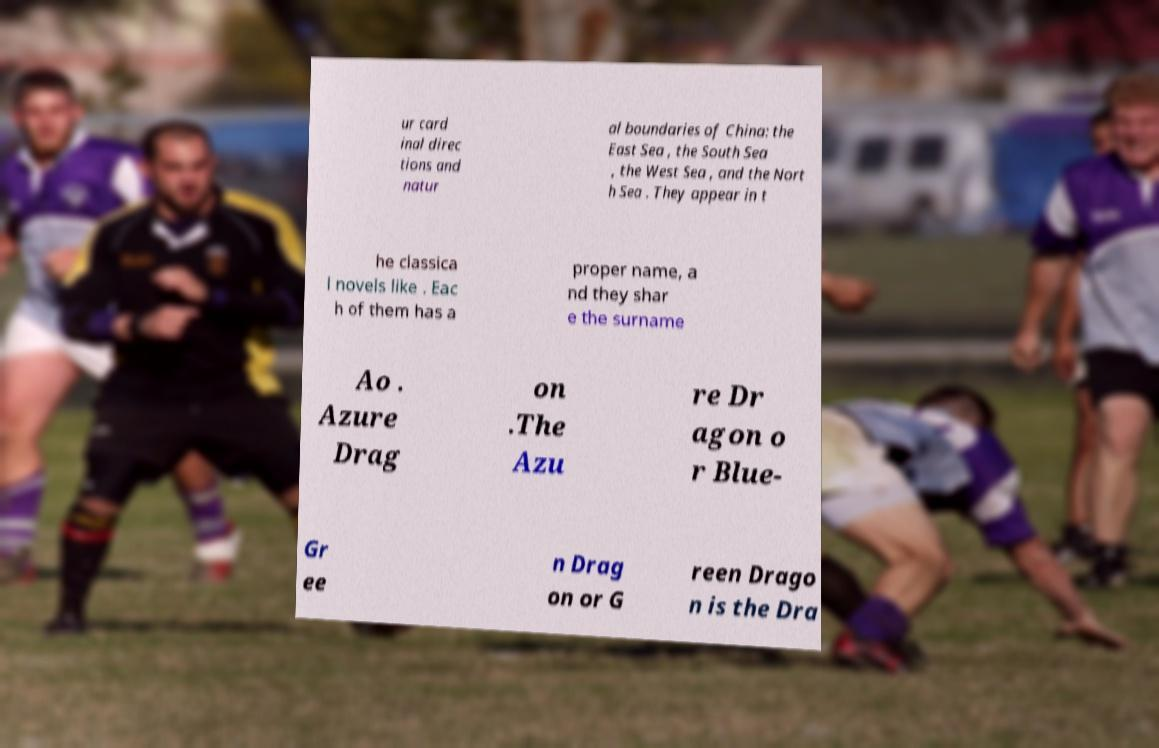Can you read and provide the text displayed in the image?This photo seems to have some interesting text. Can you extract and type it out for me? ur card inal direc tions and natur al boundaries of China: the East Sea , the South Sea , the West Sea , and the Nort h Sea . They appear in t he classica l novels like . Eac h of them has a proper name, a nd they shar e the surname Ao . Azure Drag on .The Azu re Dr agon o r Blue- Gr ee n Drag on or G reen Drago n is the Dra 